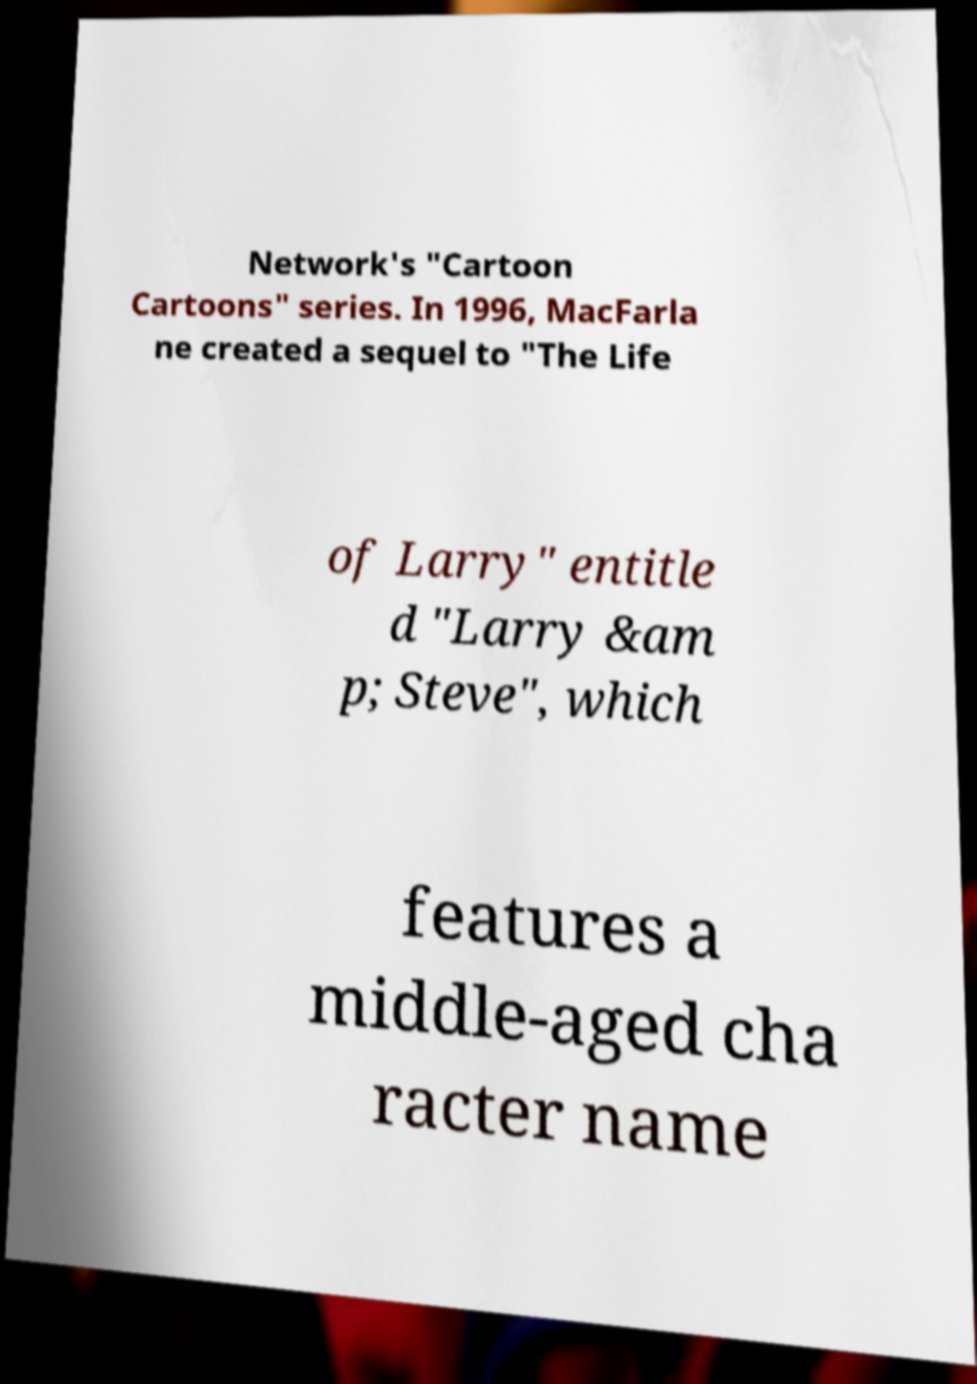Please identify and transcribe the text found in this image. Network's "Cartoon Cartoons" series. In 1996, MacFarla ne created a sequel to "The Life of Larry" entitle d "Larry &am p; Steve", which features a middle-aged cha racter name 